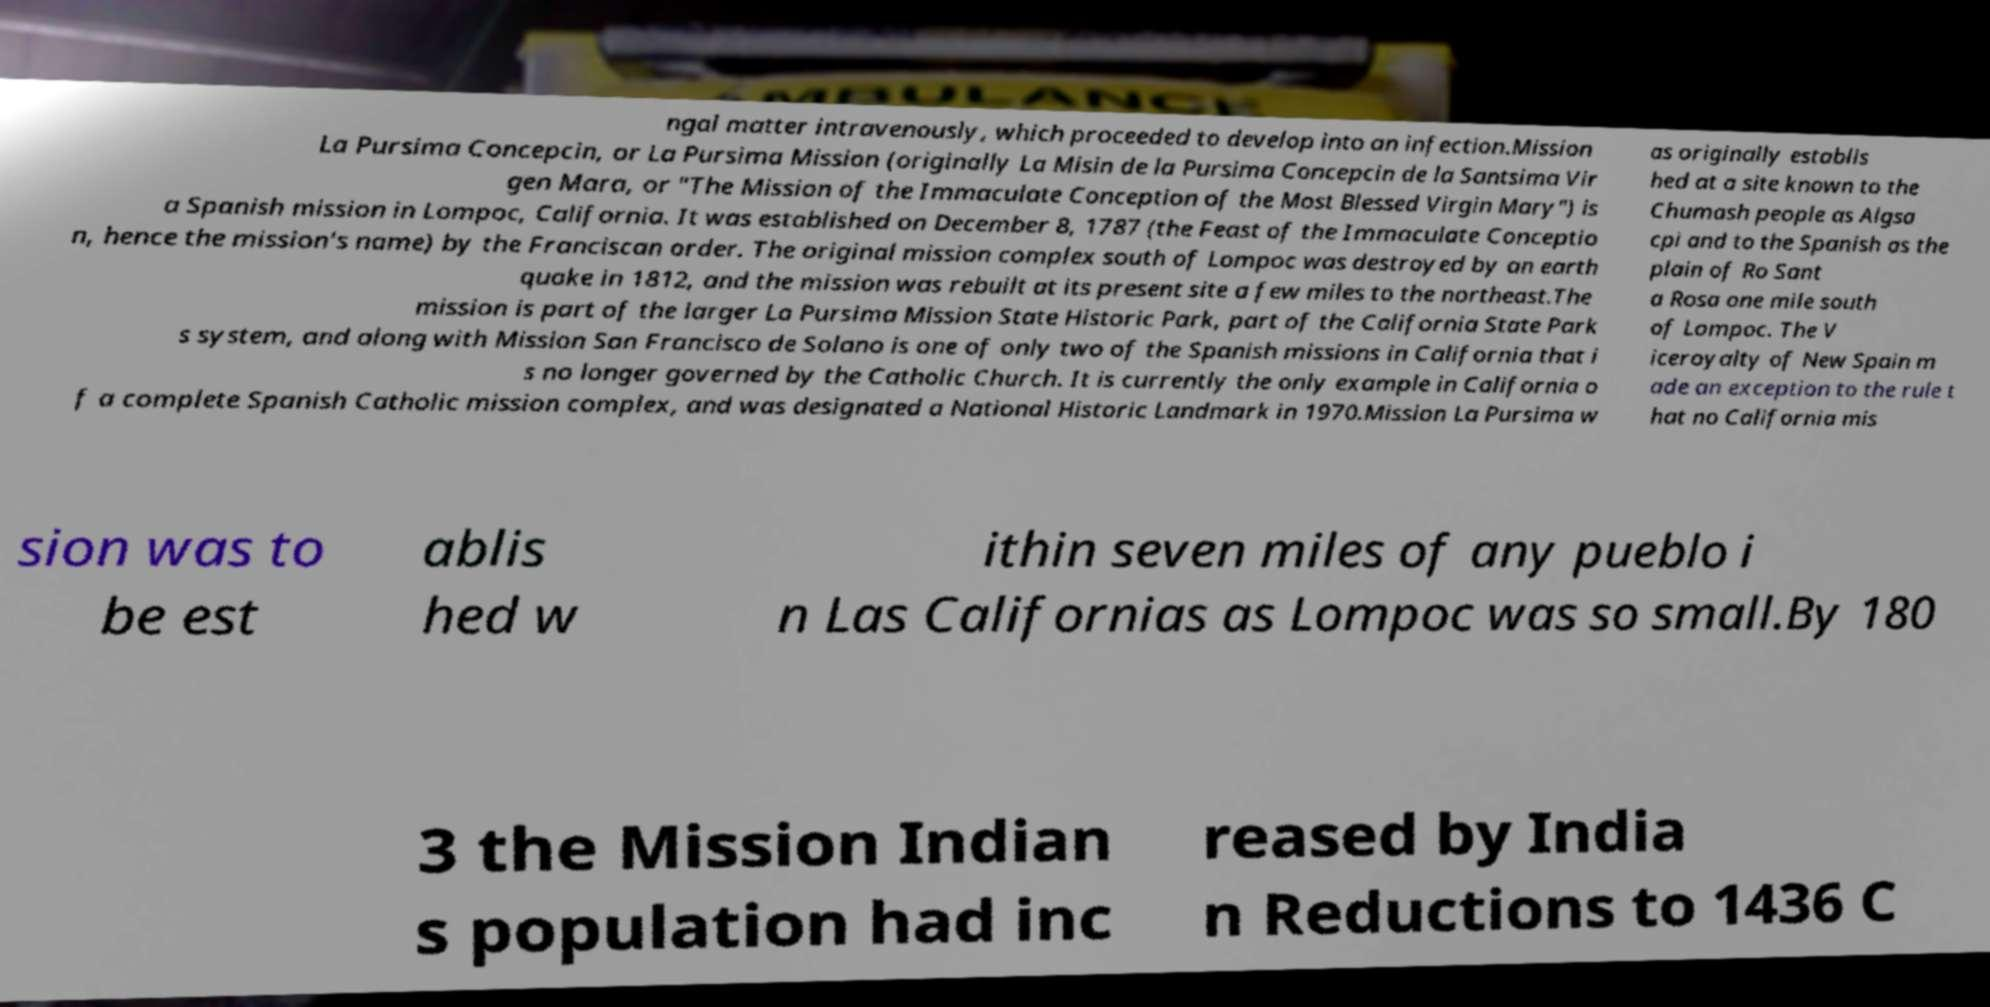I need the written content from this picture converted into text. Can you do that? ngal matter intravenously, which proceeded to develop into an infection.Mission La Pursima Concepcin, or La Pursima Mission (originally La Misin de la Pursima Concepcin de la Santsima Vir gen Mara, or "The Mission of the Immaculate Conception of the Most Blessed Virgin Mary") is a Spanish mission in Lompoc, California. It was established on December 8, 1787 (the Feast of the Immaculate Conceptio n, hence the mission's name) by the Franciscan order. The original mission complex south of Lompoc was destroyed by an earth quake in 1812, and the mission was rebuilt at its present site a few miles to the northeast.The mission is part of the larger La Pursima Mission State Historic Park, part of the California State Park s system, and along with Mission San Francisco de Solano is one of only two of the Spanish missions in California that i s no longer governed by the Catholic Church. It is currently the only example in California o f a complete Spanish Catholic mission complex, and was designated a National Historic Landmark in 1970.Mission La Pursima w as originally establis hed at a site known to the Chumash people as Algsa cpi and to the Spanish as the plain of Ro Sant a Rosa one mile south of Lompoc. The V iceroyalty of New Spain m ade an exception to the rule t hat no California mis sion was to be est ablis hed w ithin seven miles of any pueblo i n Las Californias as Lompoc was so small.By 180 3 the Mission Indian s population had inc reased by India n Reductions to 1436 C 